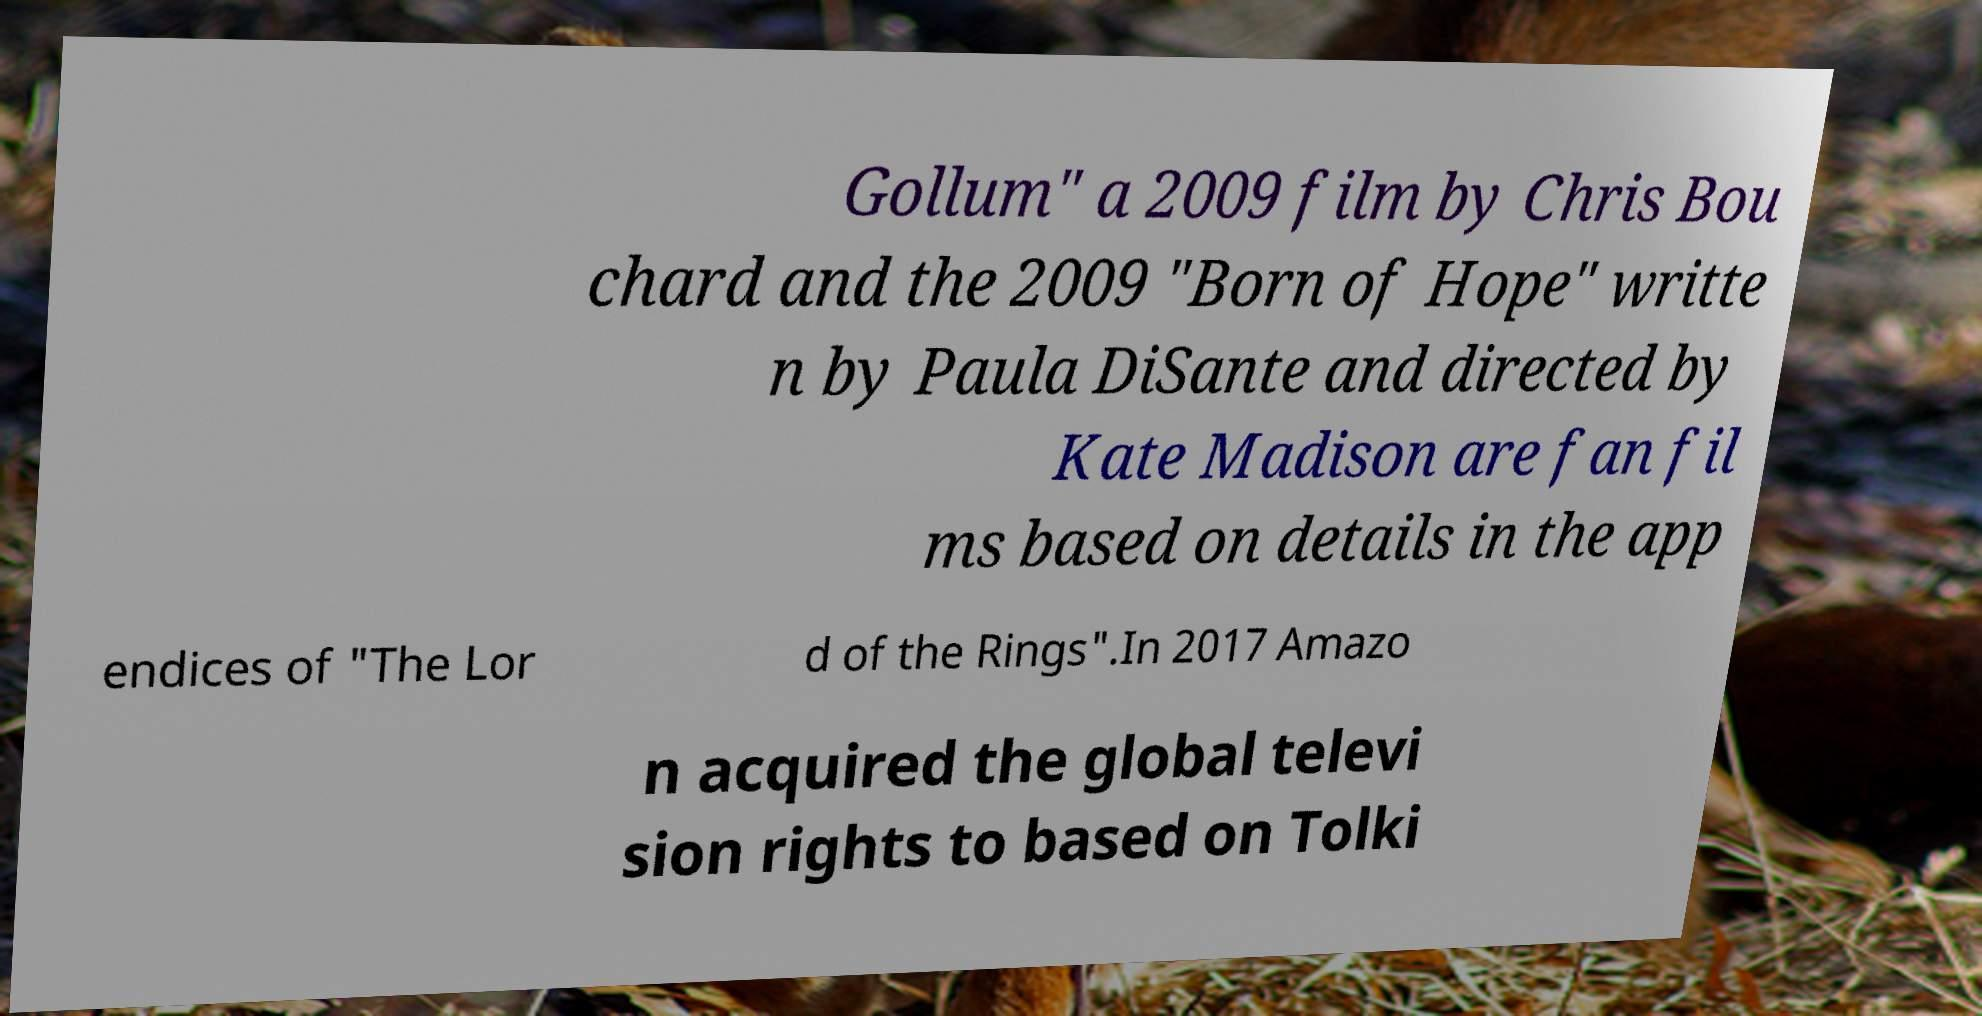Can you read and provide the text displayed in the image?This photo seems to have some interesting text. Can you extract and type it out for me? Gollum" a 2009 film by Chris Bou chard and the 2009 "Born of Hope" writte n by Paula DiSante and directed by Kate Madison are fan fil ms based on details in the app endices of "The Lor d of the Rings".In 2017 Amazo n acquired the global televi sion rights to based on Tolki 